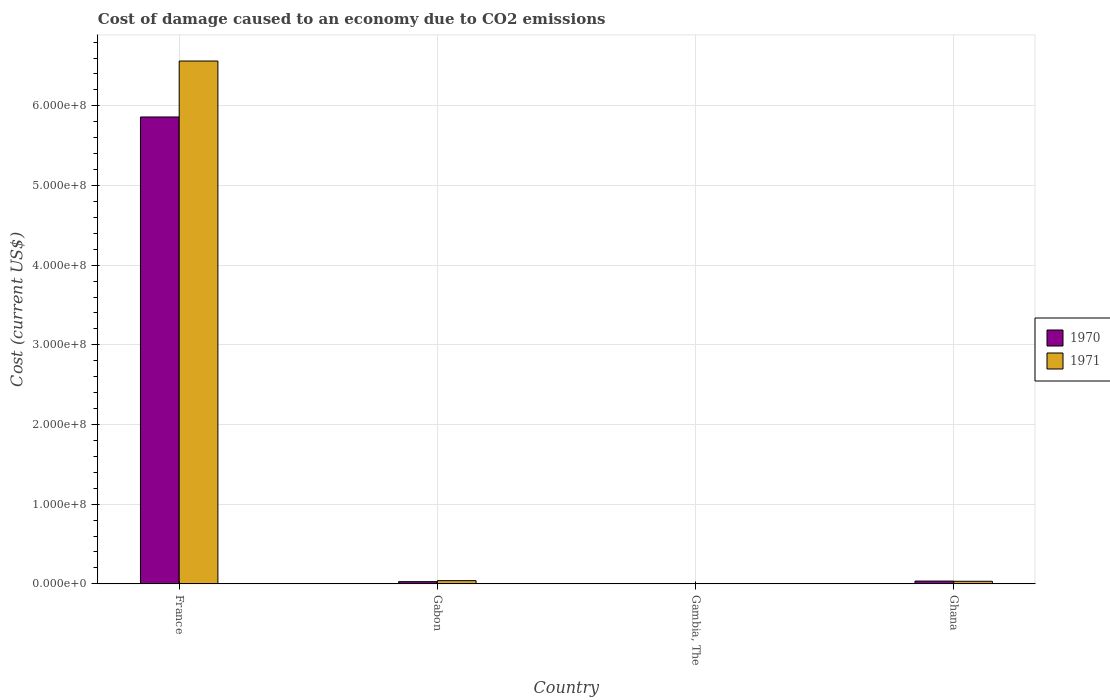How many different coloured bars are there?
Ensure brevity in your answer.  2. Are the number of bars per tick equal to the number of legend labels?
Your answer should be compact. Yes. In how many cases, is the number of bars for a given country not equal to the number of legend labels?
Give a very brief answer. 0. What is the cost of damage caused due to CO2 emissisons in 1970 in Gabon?
Provide a succinct answer. 2.78e+06. Across all countries, what is the maximum cost of damage caused due to CO2 emissisons in 1971?
Keep it short and to the point. 6.56e+08. Across all countries, what is the minimum cost of damage caused due to CO2 emissisons in 1970?
Provide a succinct answer. 6.36e+04. In which country was the cost of damage caused due to CO2 emissisons in 1970 maximum?
Keep it short and to the point. France. In which country was the cost of damage caused due to CO2 emissisons in 1971 minimum?
Your answer should be very brief. Gambia, The. What is the total cost of damage caused due to CO2 emissisons in 1971 in the graph?
Offer a terse response. 6.64e+08. What is the difference between the cost of damage caused due to CO2 emissisons in 1970 in Gabon and that in Gambia, The?
Provide a short and direct response. 2.72e+06. What is the difference between the cost of damage caused due to CO2 emissisons in 1971 in Ghana and the cost of damage caused due to CO2 emissisons in 1970 in France?
Provide a short and direct response. -5.83e+08. What is the average cost of damage caused due to CO2 emissisons in 1971 per country?
Provide a succinct answer. 1.66e+08. What is the difference between the cost of damage caused due to CO2 emissisons of/in 1971 and cost of damage caused due to CO2 emissisons of/in 1970 in Gabon?
Provide a succinct answer. 1.26e+06. In how many countries, is the cost of damage caused due to CO2 emissisons in 1971 greater than 160000000 US$?
Provide a short and direct response. 1. What is the ratio of the cost of damage caused due to CO2 emissisons in 1971 in Gambia, The to that in Ghana?
Your response must be concise. 0.02. Is the cost of damage caused due to CO2 emissisons in 1971 in Gabon less than that in Gambia, The?
Your response must be concise. No. Is the difference between the cost of damage caused due to CO2 emissisons in 1971 in France and Ghana greater than the difference between the cost of damage caused due to CO2 emissisons in 1970 in France and Ghana?
Your answer should be compact. Yes. What is the difference between the highest and the second highest cost of damage caused due to CO2 emissisons in 1971?
Keep it short and to the point. -7.81e+05. What is the difference between the highest and the lowest cost of damage caused due to CO2 emissisons in 1971?
Provide a short and direct response. 6.56e+08. What does the 1st bar from the left in France represents?
Give a very brief answer. 1970. What does the 2nd bar from the right in Gabon represents?
Make the answer very short. 1970. How many countries are there in the graph?
Your answer should be compact. 4. What is the difference between two consecutive major ticks on the Y-axis?
Offer a very short reply. 1.00e+08. Does the graph contain grids?
Your answer should be very brief. Yes. How many legend labels are there?
Your answer should be very brief. 2. What is the title of the graph?
Provide a short and direct response. Cost of damage caused to an economy due to CO2 emissions. What is the label or title of the X-axis?
Make the answer very short. Country. What is the label or title of the Y-axis?
Keep it short and to the point. Cost (current US$). What is the Cost (current US$) in 1970 in France?
Your answer should be compact. 5.86e+08. What is the Cost (current US$) of 1971 in France?
Your answer should be very brief. 6.56e+08. What is the Cost (current US$) of 1970 in Gabon?
Provide a succinct answer. 2.78e+06. What is the Cost (current US$) in 1971 in Gabon?
Give a very brief answer. 4.04e+06. What is the Cost (current US$) of 1970 in Gambia, The?
Keep it short and to the point. 6.36e+04. What is the Cost (current US$) in 1971 in Gambia, The?
Offer a terse response. 7.81e+04. What is the Cost (current US$) of 1970 in Ghana?
Provide a succinct answer. 3.50e+06. What is the Cost (current US$) in 1971 in Ghana?
Give a very brief answer. 3.26e+06. Across all countries, what is the maximum Cost (current US$) of 1970?
Your response must be concise. 5.86e+08. Across all countries, what is the maximum Cost (current US$) in 1971?
Offer a terse response. 6.56e+08. Across all countries, what is the minimum Cost (current US$) in 1970?
Offer a very short reply. 6.36e+04. Across all countries, what is the minimum Cost (current US$) in 1971?
Offer a terse response. 7.81e+04. What is the total Cost (current US$) in 1970 in the graph?
Offer a terse response. 5.92e+08. What is the total Cost (current US$) of 1971 in the graph?
Keep it short and to the point. 6.64e+08. What is the difference between the Cost (current US$) in 1970 in France and that in Gabon?
Provide a succinct answer. 5.83e+08. What is the difference between the Cost (current US$) of 1971 in France and that in Gabon?
Your answer should be very brief. 6.52e+08. What is the difference between the Cost (current US$) in 1970 in France and that in Gambia, The?
Your answer should be very brief. 5.86e+08. What is the difference between the Cost (current US$) of 1971 in France and that in Gambia, The?
Your answer should be compact. 6.56e+08. What is the difference between the Cost (current US$) in 1970 in France and that in Ghana?
Provide a succinct answer. 5.82e+08. What is the difference between the Cost (current US$) in 1971 in France and that in Ghana?
Provide a short and direct response. 6.53e+08. What is the difference between the Cost (current US$) in 1970 in Gabon and that in Gambia, The?
Provide a short and direct response. 2.72e+06. What is the difference between the Cost (current US$) in 1971 in Gabon and that in Gambia, The?
Keep it short and to the point. 3.96e+06. What is the difference between the Cost (current US$) of 1970 in Gabon and that in Ghana?
Offer a terse response. -7.24e+05. What is the difference between the Cost (current US$) of 1971 in Gabon and that in Ghana?
Make the answer very short. 7.81e+05. What is the difference between the Cost (current US$) of 1970 in Gambia, The and that in Ghana?
Offer a very short reply. -3.44e+06. What is the difference between the Cost (current US$) in 1971 in Gambia, The and that in Ghana?
Offer a terse response. -3.18e+06. What is the difference between the Cost (current US$) of 1970 in France and the Cost (current US$) of 1971 in Gabon?
Provide a short and direct response. 5.82e+08. What is the difference between the Cost (current US$) of 1970 in France and the Cost (current US$) of 1971 in Gambia, The?
Ensure brevity in your answer.  5.86e+08. What is the difference between the Cost (current US$) in 1970 in France and the Cost (current US$) in 1971 in Ghana?
Offer a very short reply. 5.83e+08. What is the difference between the Cost (current US$) of 1970 in Gabon and the Cost (current US$) of 1971 in Gambia, The?
Provide a succinct answer. 2.70e+06. What is the difference between the Cost (current US$) of 1970 in Gabon and the Cost (current US$) of 1971 in Ghana?
Keep it short and to the point. -4.77e+05. What is the difference between the Cost (current US$) of 1970 in Gambia, The and the Cost (current US$) of 1971 in Ghana?
Make the answer very short. -3.19e+06. What is the average Cost (current US$) of 1970 per country?
Your answer should be compact. 1.48e+08. What is the average Cost (current US$) of 1971 per country?
Give a very brief answer. 1.66e+08. What is the difference between the Cost (current US$) in 1970 and Cost (current US$) in 1971 in France?
Offer a very short reply. -7.02e+07. What is the difference between the Cost (current US$) of 1970 and Cost (current US$) of 1971 in Gabon?
Provide a succinct answer. -1.26e+06. What is the difference between the Cost (current US$) in 1970 and Cost (current US$) in 1971 in Gambia, The?
Your answer should be compact. -1.44e+04. What is the difference between the Cost (current US$) in 1970 and Cost (current US$) in 1971 in Ghana?
Your response must be concise. 2.47e+05. What is the ratio of the Cost (current US$) of 1970 in France to that in Gabon?
Provide a succinct answer. 210.77. What is the ratio of the Cost (current US$) in 1971 in France to that in Gabon?
Ensure brevity in your answer.  162.51. What is the ratio of the Cost (current US$) in 1970 in France to that in Gambia, The?
Keep it short and to the point. 9209.23. What is the ratio of the Cost (current US$) in 1971 in France to that in Gambia, The?
Offer a very short reply. 8407.13. What is the ratio of the Cost (current US$) of 1970 in France to that in Ghana?
Make the answer very short. 167.21. What is the ratio of the Cost (current US$) of 1971 in France to that in Ghana?
Provide a succinct answer. 201.45. What is the ratio of the Cost (current US$) of 1970 in Gabon to that in Gambia, The?
Give a very brief answer. 43.69. What is the ratio of the Cost (current US$) in 1971 in Gabon to that in Gambia, The?
Provide a short and direct response. 51.73. What is the ratio of the Cost (current US$) of 1970 in Gabon to that in Ghana?
Your answer should be very brief. 0.79. What is the ratio of the Cost (current US$) in 1971 in Gabon to that in Ghana?
Provide a succinct answer. 1.24. What is the ratio of the Cost (current US$) of 1970 in Gambia, The to that in Ghana?
Make the answer very short. 0.02. What is the ratio of the Cost (current US$) in 1971 in Gambia, The to that in Ghana?
Give a very brief answer. 0.02. What is the difference between the highest and the second highest Cost (current US$) of 1970?
Ensure brevity in your answer.  5.82e+08. What is the difference between the highest and the second highest Cost (current US$) of 1971?
Give a very brief answer. 6.52e+08. What is the difference between the highest and the lowest Cost (current US$) in 1970?
Ensure brevity in your answer.  5.86e+08. What is the difference between the highest and the lowest Cost (current US$) in 1971?
Give a very brief answer. 6.56e+08. 